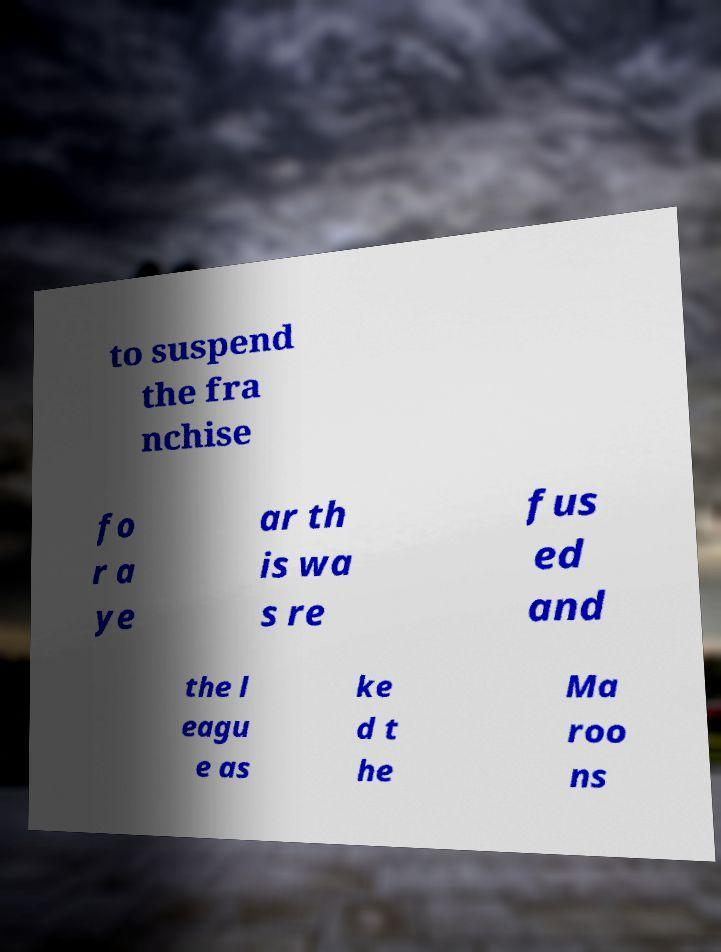Can you accurately transcribe the text from the provided image for me? to suspend the fra nchise fo r a ye ar th is wa s re fus ed and the l eagu e as ke d t he Ma roo ns 